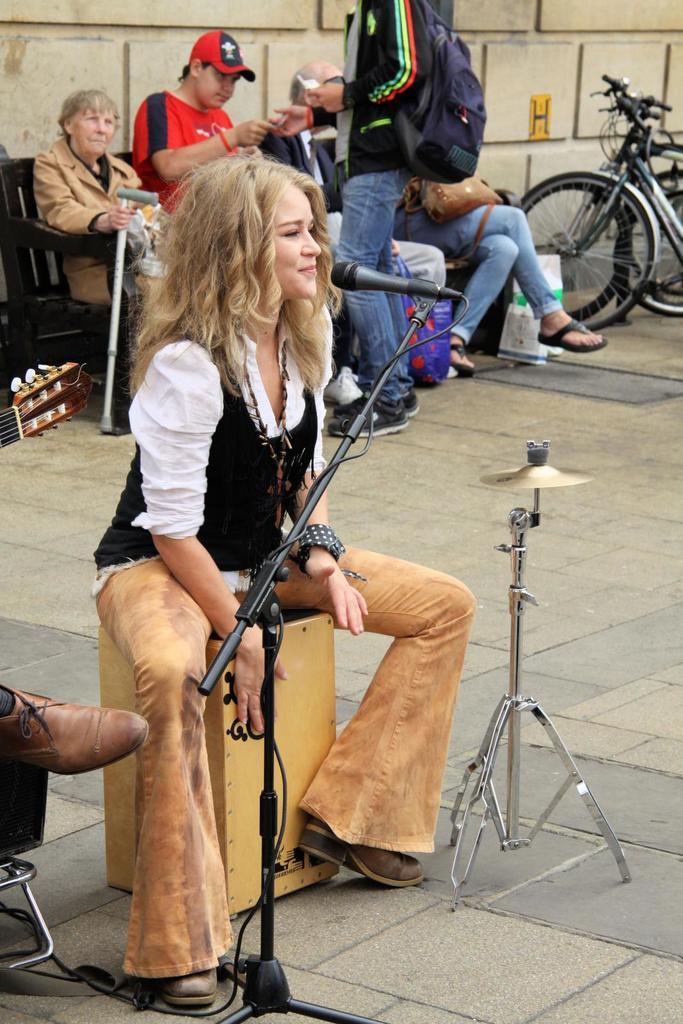Please provide a concise description of this image. In this image we can see a girl is sitting on a yellow color box and playing it. She is wearing white and black color dress. In front of her mic is there. Behind her people are sitting on the bench. Right side of the image bicycles are are present. Beside girl one tripod stand is there. 